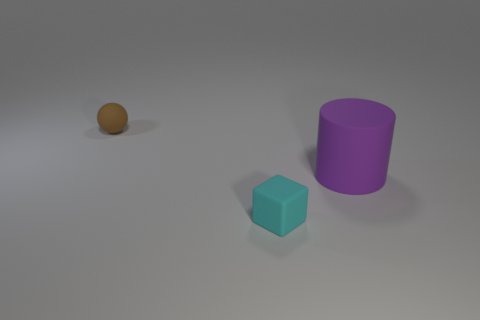The tiny block has what color?
Your response must be concise. Cyan. How big is the object that is to the right of the cyan object?
Keep it short and to the point. Large. There is a rubber thing that is in front of the object that is to the right of the cube; how many large cylinders are on the left side of it?
Give a very brief answer. 0. There is a small object that is to the left of the tiny rubber thing that is on the right side of the brown ball; what color is it?
Your answer should be compact. Brown. Are there any rubber cylinders that have the same size as the sphere?
Keep it short and to the point. No. There is a small object that is behind the thing on the right side of the thing in front of the big purple cylinder; what is it made of?
Make the answer very short. Rubber. What number of matte spheres are on the right side of the thing that is behind the matte cylinder?
Give a very brief answer. 0. There is a object that is behind the purple cylinder; is its size the same as the tiny cyan matte block?
Offer a very short reply. Yes. What number of small cyan objects are the same shape as the big purple thing?
Your answer should be very brief. 0. What is the shape of the large object?
Your response must be concise. Cylinder. 